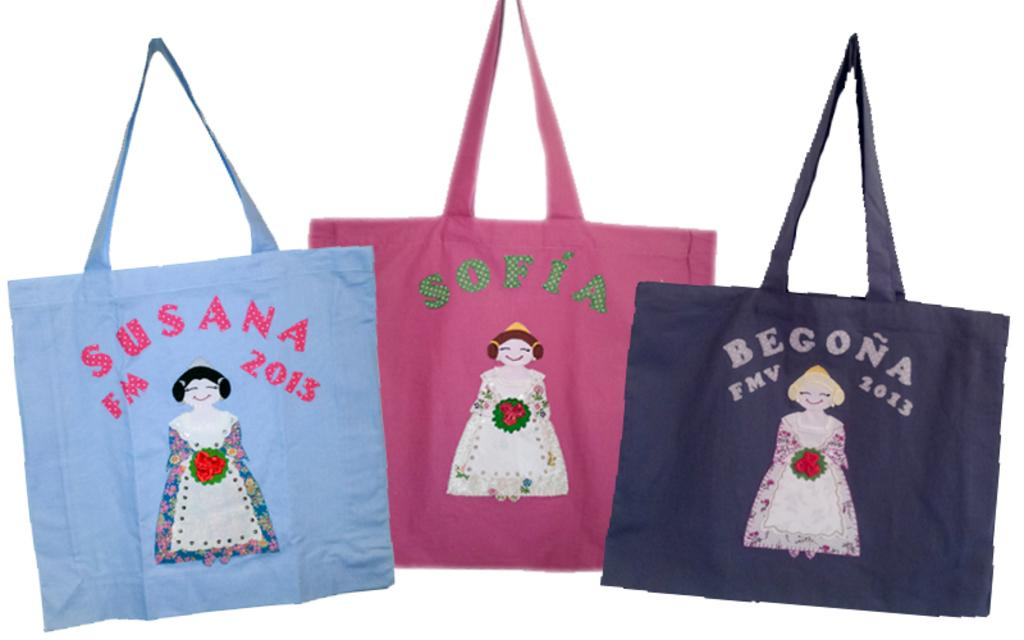How many handbags are visible in the image? There are three handbags in the image. What colors are the handbags? The handbags are blue, pink, and black in color. What is the woman in the image holding? The woman is holding a bouquet in the image. Can you see a locket on the blue handbag in the image? There is no locket visible on the blue handbag in the image. 